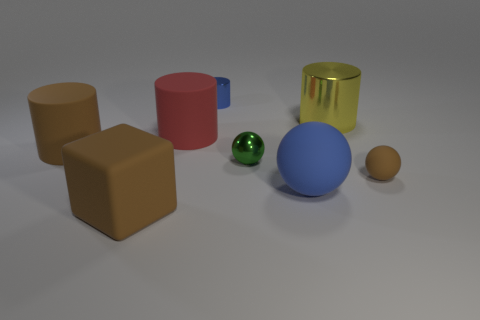Subtract all matte spheres. How many spheres are left? 1 Subtract all yellow cylinders. How many cylinders are left? 3 Subtract 1 cylinders. How many cylinders are left? 3 Subtract all cyan blocks. How many purple cylinders are left? 0 Subtract 0 green blocks. How many objects are left? 8 Subtract all blocks. How many objects are left? 7 Subtract all purple cubes. Subtract all green cylinders. How many cubes are left? 1 Subtract all small metallic cylinders. Subtract all metal objects. How many objects are left? 4 Add 7 metallic spheres. How many metallic spheres are left? 8 Add 6 small blue shiny objects. How many small blue shiny objects exist? 7 